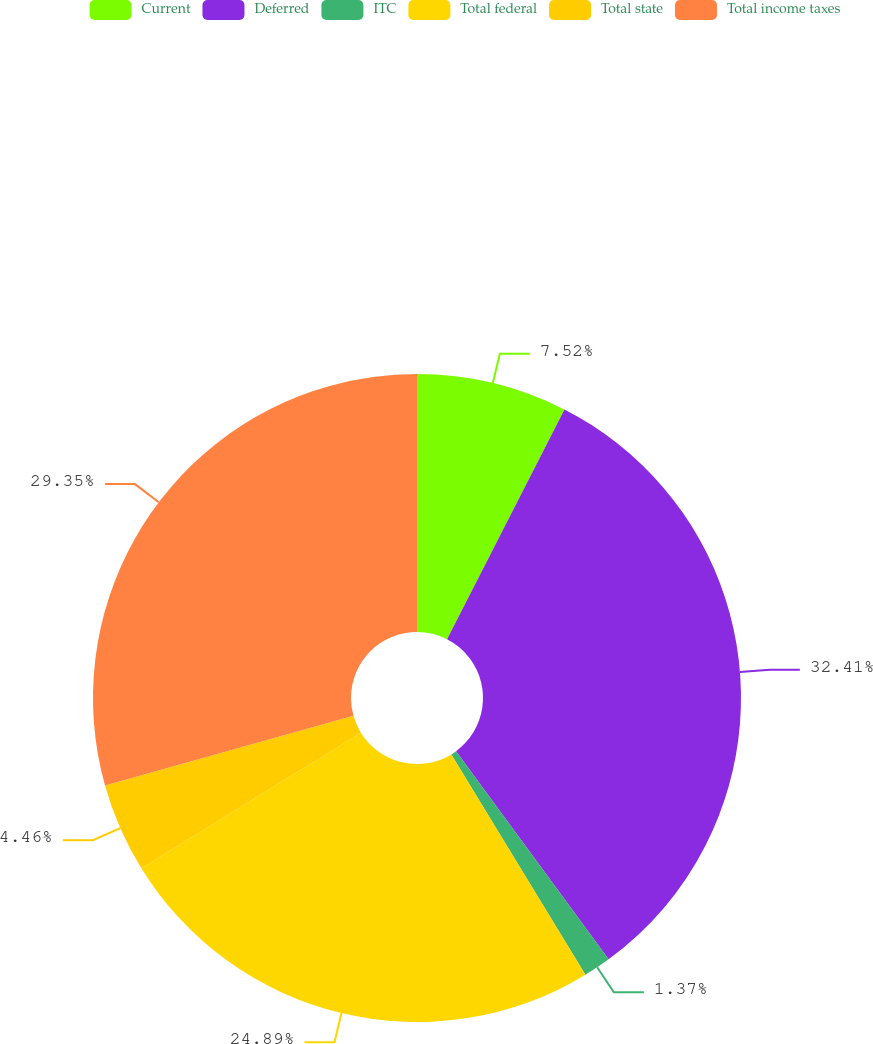Convert chart. <chart><loc_0><loc_0><loc_500><loc_500><pie_chart><fcel>Current<fcel>Deferred<fcel>ITC<fcel>Total federal<fcel>Total state<fcel>Total income taxes<nl><fcel>7.52%<fcel>32.41%<fcel>1.37%<fcel>24.89%<fcel>4.46%<fcel>29.35%<nl></chart> 